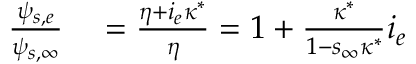Convert formula to latex. <formula><loc_0><loc_0><loc_500><loc_500>\begin{array} { r l } { \frac { \psi _ { s , e } } { \psi _ { s , \infty } } } & = \frac { \eta + i _ { e } \kappa ^ { * } } { \eta } = 1 + \frac { \kappa ^ { * } } { 1 - s _ { \infty } \kappa ^ { * } } i _ { e } } \end{array}</formula> 